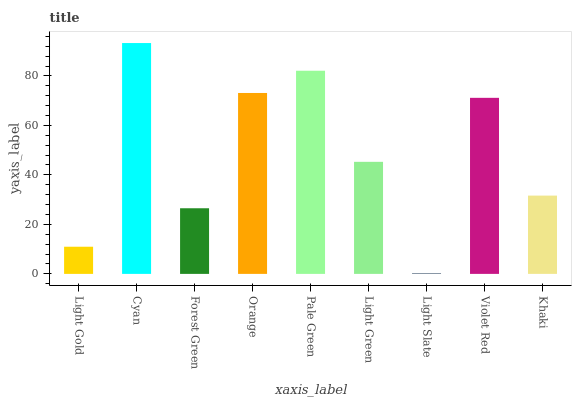Is Light Slate the minimum?
Answer yes or no. Yes. Is Cyan the maximum?
Answer yes or no. Yes. Is Forest Green the minimum?
Answer yes or no. No. Is Forest Green the maximum?
Answer yes or no. No. Is Cyan greater than Forest Green?
Answer yes or no. Yes. Is Forest Green less than Cyan?
Answer yes or no. Yes. Is Forest Green greater than Cyan?
Answer yes or no. No. Is Cyan less than Forest Green?
Answer yes or no. No. Is Light Green the high median?
Answer yes or no. Yes. Is Light Green the low median?
Answer yes or no. Yes. Is Pale Green the high median?
Answer yes or no. No. Is Khaki the low median?
Answer yes or no. No. 